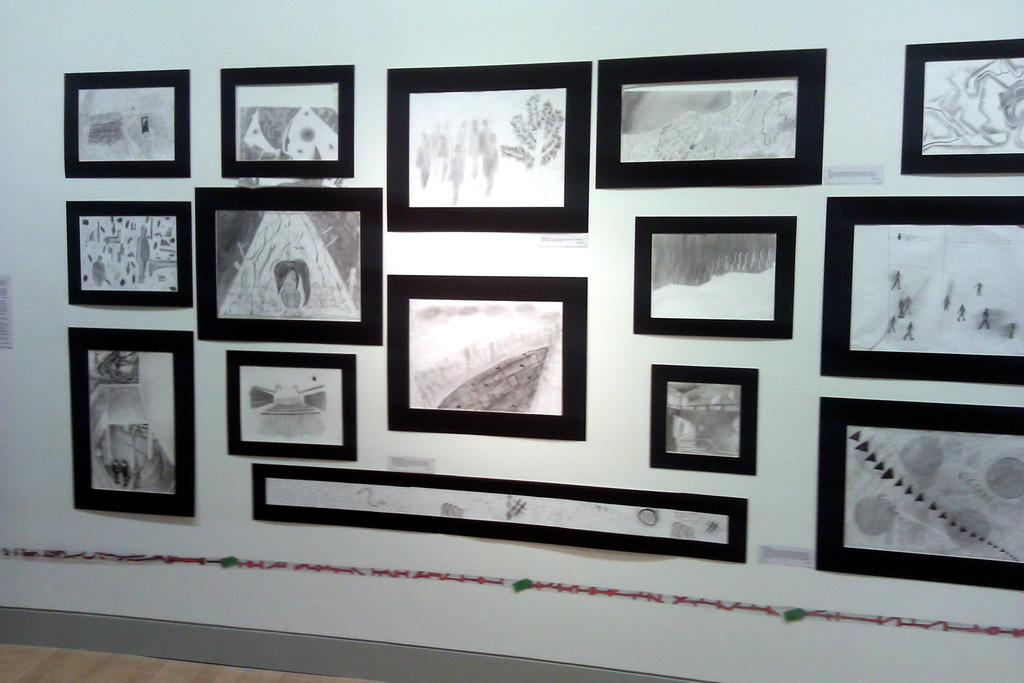Where was the image most likely taken? The image is likely taken inside a room. What can be seen on the wall in the image? There is a wall visible in the image, and photo frames are attached to it. What type of wrench is being used to adjust the arch in the image? There is no wrench or arch present in the image; it only features a wall with photo frames attached to it. 